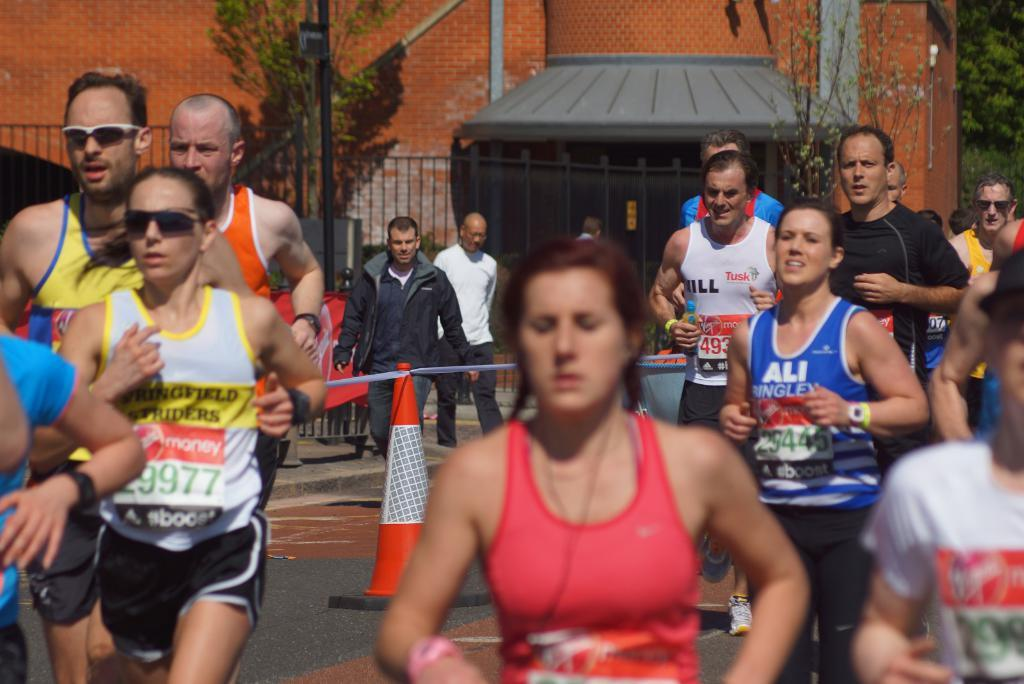<image>
Offer a succinct explanation of the picture presented. Some runners, one of whom has the name Ali on their vest. 